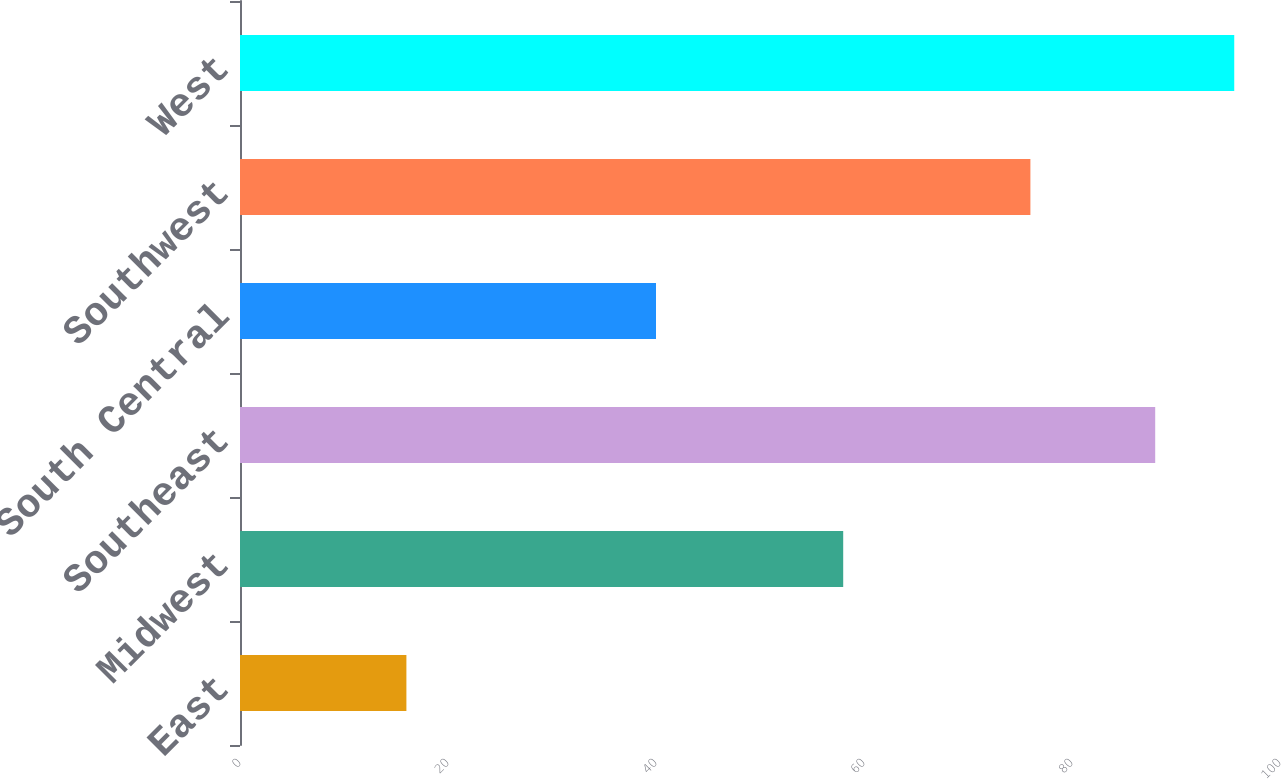<chart> <loc_0><loc_0><loc_500><loc_500><bar_chart><fcel>East<fcel>Midwest<fcel>Southeast<fcel>South Central<fcel>Southwest<fcel>West<nl><fcel>16<fcel>58<fcel>88<fcel>40<fcel>76<fcel>95.6<nl></chart> 